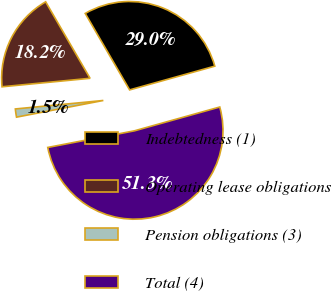Convert chart to OTSL. <chart><loc_0><loc_0><loc_500><loc_500><pie_chart><fcel>Indebtedness (1)<fcel>Operating lease obligations<fcel>Pension obligations (3)<fcel>Total (4)<nl><fcel>29.04%<fcel>18.16%<fcel>1.49%<fcel>51.31%<nl></chart> 